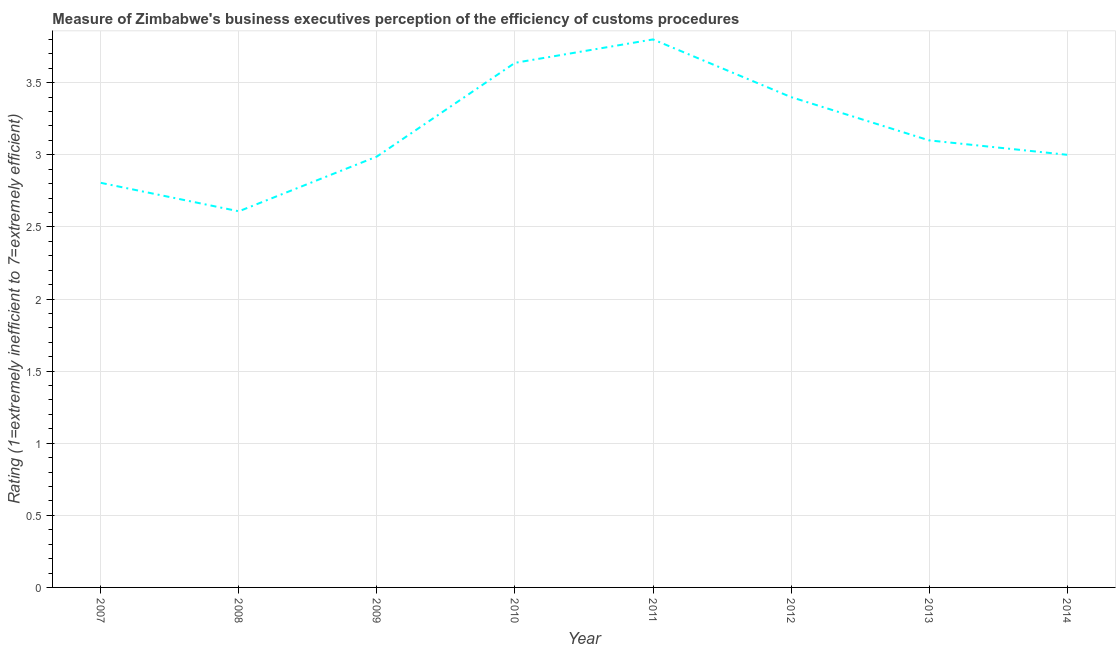Across all years, what is the maximum rating measuring burden of customs procedure?
Ensure brevity in your answer.  3.8. Across all years, what is the minimum rating measuring burden of customs procedure?
Provide a short and direct response. 2.61. In which year was the rating measuring burden of customs procedure maximum?
Offer a very short reply. 2011. In which year was the rating measuring burden of customs procedure minimum?
Keep it short and to the point. 2008. What is the sum of the rating measuring burden of customs procedure?
Ensure brevity in your answer.  25.34. What is the difference between the rating measuring burden of customs procedure in 2012 and 2014?
Give a very brief answer. 0.4. What is the average rating measuring burden of customs procedure per year?
Ensure brevity in your answer.  3.17. What is the median rating measuring burden of customs procedure?
Your response must be concise. 3.05. What is the ratio of the rating measuring burden of customs procedure in 2007 to that in 2011?
Give a very brief answer. 0.74. Is the rating measuring burden of customs procedure in 2007 less than that in 2014?
Provide a succinct answer. Yes. What is the difference between the highest and the second highest rating measuring burden of customs procedure?
Ensure brevity in your answer.  0.16. Is the sum of the rating measuring burden of customs procedure in 2011 and 2013 greater than the maximum rating measuring burden of customs procedure across all years?
Keep it short and to the point. Yes. What is the difference between the highest and the lowest rating measuring burden of customs procedure?
Provide a succinct answer. 1.19. In how many years, is the rating measuring burden of customs procedure greater than the average rating measuring burden of customs procedure taken over all years?
Make the answer very short. 3. Does the rating measuring burden of customs procedure monotonically increase over the years?
Your response must be concise. No. Does the graph contain grids?
Your response must be concise. Yes. What is the title of the graph?
Give a very brief answer. Measure of Zimbabwe's business executives perception of the efficiency of customs procedures. What is the label or title of the Y-axis?
Give a very brief answer. Rating (1=extremely inefficient to 7=extremely efficient). What is the Rating (1=extremely inefficient to 7=extremely efficient) of 2007?
Keep it short and to the point. 2.81. What is the Rating (1=extremely inefficient to 7=extremely efficient) in 2008?
Provide a short and direct response. 2.61. What is the Rating (1=extremely inefficient to 7=extremely efficient) in 2009?
Your answer should be very brief. 2.99. What is the Rating (1=extremely inefficient to 7=extremely efficient) in 2010?
Keep it short and to the point. 3.64. What is the Rating (1=extremely inefficient to 7=extremely efficient) of 2011?
Make the answer very short. 3.8. What is the Rating (1=extremely inefficient to 7=extremely efficient) of 2013?
Your response must be concise. 3.1. What is the Rating (1=extremely inefficient to 7=extremely efficient) of 2014?
Your response must be concise. 3. What is the difference between the Rating (1=extremely inefficient to 7=extremely efficient) in 2007 and 2008?
Make the answer very short. 0.2. What is the difference between the Rating (1=extremely inefficient to 7=extremely efficient) in 2007 and 2009?
Your response must be concise. -0.18. What is the difference between the Rating (1=extremely inefficient to 7=extremely efficient) in 2007 and 2010?
Your answer should be compact. -0.83. What is the difference between the Rating (1=extremely inefficient to 7=extremely efficient) in 2007 and 2011?
Give a very brief answer. -0.99. What is the difference between the Rating (1=extremely inefficient to 7=extremely efficient) in 2007 and 2012?
Your answer should be compact. -0.59. What is the difference between the Rating (1=extremely inefficient to 7=extremely efficient) in 2007 and 2013?
Ensure brevity in your answer.  -0.29. What is the difference between the Rating (1=extremely inefficient to 7=extremely efficient) in 2007 and 2014?
Make the answer very short. -0.19. What is the difference between the Rating (1=extremely inefficient to 7=extremely efficient) in 2008 and 2009?
Your answer should be very brief. -0.38. What is the difference between the Rating (1=extremely inefficient to 7=extremely efficient) in 2008 and 2010?
Provide a short and direct response. -1.03. What is the difference between the Rating (1=extremely inefficient to 7=extremely efficient) in 2008 and 2011?
Your answer should be compact. -1.19. What is the difference between the Rating (1=extremely inefficient to 7=extremely efficient) in 2008 and 2012?
Give a very brief answer. -0.79. What is the difference between the Rating (1=extremely inefficient to 7=extremely efficient) in 2008 and 2013?
Your response must be concise. -0.49. What is the difference between the Rating (1=extremely inefficient to 7=extremely efficient) in 2008 and 2014?
Offer a terse response. -0.39. What is the difference between the Rating (1=extremely inefficient to 7=extremely efficient) in 2009 and 2010?
Give a very brief answer. -0.65. What is the difference between the Rating (1=extremely inefficient to 7=extremely efficient) in 2009 and 2011?
Your answer should be very brief. -0.81. What is the difference between the Rating (1=extremely inefficient to 7=extremely efficient) in 2009 and 2012?
Give a very brief answer. -0.41. What is the difference between the Rating (1=extremely inefficient to 7=extremely efficient) in 2009 and 2013?
Ensure brevity in your answer.  -0.11. What is the difference between the Rating (1=extremely inefficient to 7=extremely efficient) in 2009 and 2014?
Provide a short and direct response. -0.01. What is the difference between the Rating (1=extremely inefficient to 7=extremely efficient) in 2010 and 2011?
Make the answer very short. -0.16. What is the difference between the Rating (1=extremely inefficient to 7=extremely efficient) in 2010 and 2012?
Provide a succinct answer. 0.24. What is the difference between the Rating (1=extremely inefficient to 7=extremely efficient) in 2010 and 2013?
Ensure brevity in your answer.  0.54. What is the difference between the Rating (1=extremely inefficient to 7=extremely efficient) in 2010 and 2014?
Provide a short and direct response. 0.64. What is the difference between the Rating (1=extremely inefficient to 7=extremely efficient) in 2011 and 2013?
Keep it short and to the point. 0.7. What is the difference between the Rating (1=extremely inefficient to 7=extremely efficient) in 2011 and 2014?
Offer a very short reply. 0.8. What is the ratio of the Rating (1=extremely inefficient to 7=extremely efficient) in 2007 to that in 2008?
Provide a short and direct response. 1.08. What is the ratio of the Rating (1=extremely inefficient to 7=extremely efficient) in 2007 to that in 2009?
Offer a very short reply. 0.94. What is the ratio of the Rating (1=extremely inefficient to 7=extremely efficient) in 2007 to that in 2010?
Offer a terse response. 0.77. What is the ratio of the Rating (1=extremely inefficient to 7=extremely efficient) in 2007 to that in 2011?
Ensure brevity in your answer.  0.74. What is the ratio of the Rating (1=extremely inefficient to 7=extremely efficient) in 2007 to that in 2012?
Your answer should be very brief. 0.82. What is the ratio of the Rating (1=extremely inefficient to 7=extremely efficient) in 2007 to that in 2013?
Offer a terse response. 0.91. What is the ratio of the Rating (1=extremely inefficient to 7=extremely efficient) in 2007 to that in 2014?
Provide a short and direct response. 0.94. What is the ratio of the Rating (1=extremely inefficient to 7=extremely efficient) in 2008 to that in 2009?
Keep it short and to the point. 0.87. What is the ratio of the Rating (1=extremely inefficient to 7=extremely efficient) in 2008 to that in 2010?
Your answer should be very brief. 0.72. What is the ratio of the Rating (1=extremely inefficient to 7=extremely efficient) in 2008 to that in 2011?
Provide a short and direct response. 0.69. What is the ratio of the Rating (1=extremely inefficient to 7=extremely efficient) in 2008 to that in 2012?
Offer a terse response. 0.77. What is the ratio of the Rating (1=extremely inefficient to 7=extremely efficient) in 2008 to that in 2013?
Provide a short and direct response. 0.84. What is the ratio of the Rating (1=extremely inefficient to 7=extremely efficient) in 2008 to that in 2014?
Offer a very short reply. 0.87. What is the ratio of the Rating (1=extremely inefficient to 7=extremely efficient) in 2009 to that in 2010?
Your answer should be very brief. 0.82. What is the ratio of the Rating (1=extremely inefficient to 7=extremely efficient) in 2009 to that in 2011?
Make the answer very short. 0.79. What is the ratio of the Rating (1=extremely inefficient to 7=extremely efficient) in 2009 to that in 2012?
Make the answer very short. 0.88. What is the ratio of the Rating (1=extremely inefficient to 7=extremely efficient) in 2009 to that in 2013?
Offer a very short reply. 0.96. What is the ratio of the Rating (1=extremely inefficient to 7=extremely efficient) in 2010 to that in 2012?
Provide a short and direct response. 1.07. What is the ratio of the Rating (1=extremely inefficient to 7=extremely efficient) in 2010 to that in 2013?
Give a very brief answer. 1.17. What is the ratio of the Rating (1=extremely inefficient to 7=extremely efficient) in 2010 to that in 2014?
Offer a terse response. 1.21. What is the ratio of the Rating (1=extremely inefficient to 7=extremely efficient) in 2011 to that in 2012?
Ensure brevity in your answer.  1.12. What is the ratio of the Rating (1=extremely inefficient to 7=extremely efficient) in 2011 to that in 2013?
Offer a terse response. 1.23. What is the ratio of the Rating (1=extremely inefficient to 7=extremely efficient) in 2011 to that in 2014?
Make the answer very short. 1.27. What is the ratio of the Rating (1=extremely inefficient to 7=extremely efficient) in 2012 to that in 2013?
Ensure brevity in your answer.  1.1. What is the ratio of the Rating (1=extremely inefficient to 7=extremely efficient) in 2012 to that in 2014?
Offer a very short reply. 1.13. What is the ratio of the Rating (1=extremely inefficient to 7=extremely efficient) in 2013 to that in 2014?
Your response must be concise. 1.03. 